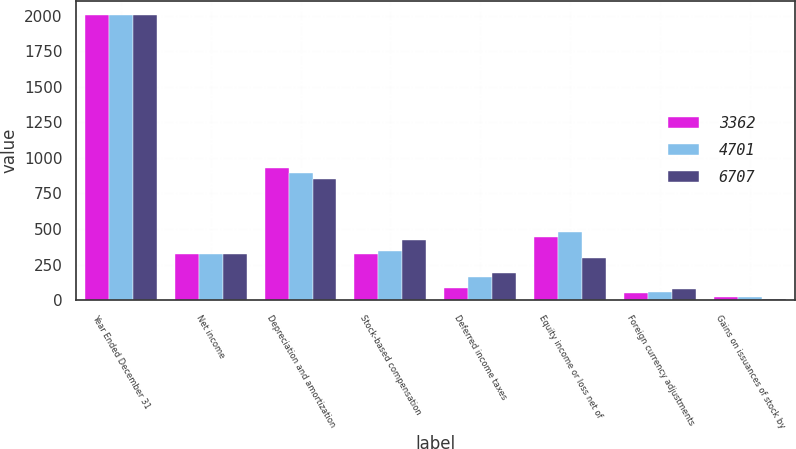Convert chart to OTSL. <chart><loc_0><loc_0><loc_500><loc_500><stacked_bar_chart><ecel><fcel>Year Ended December 31<fcel>Net income<fcel>Depreciation and amortization<fcel>Stock-based compensation<fcel>Deferred income taxes<fcel>Equity income or loss net of<fcel>Foreign currency adjustments<fcel>Gains on issuances of stock by<nl><fcel>3362<fcel>2005<fcel>324<fcel>932<fcel>324<fcel>88<fcel>446<fcel>47<fcel>23<nl><fcel>4701<fcel>2004<fcel>324<fcel>893<fcel>345<fcel>162<fcel>476<fcel>59<fcel>24<nl><fcel>6707<fcel>2003<fcel>324<fcel>850<fcel>422<fcel>188<fcel>294<fcel>79<fcel>8<nl></chart> 